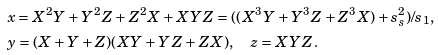<formula> <loc_0><loc_0><loc_500><loc_500>& x = X ^ { 2 } Y + Y ^ { 2 } Z + Z ^ { 2 } X + X Y Z = ( ( X ^ { 3 } Y + Y ^ { 3 } Z + Z ^ { 3 } X ) + s _ { s } ^ { 2 } ) / s _ { 1 } , \\ & y = ( X + Y + Z ) ( X Y + Y Z + Z X ) , \quad z = X Y Z .</formula> 